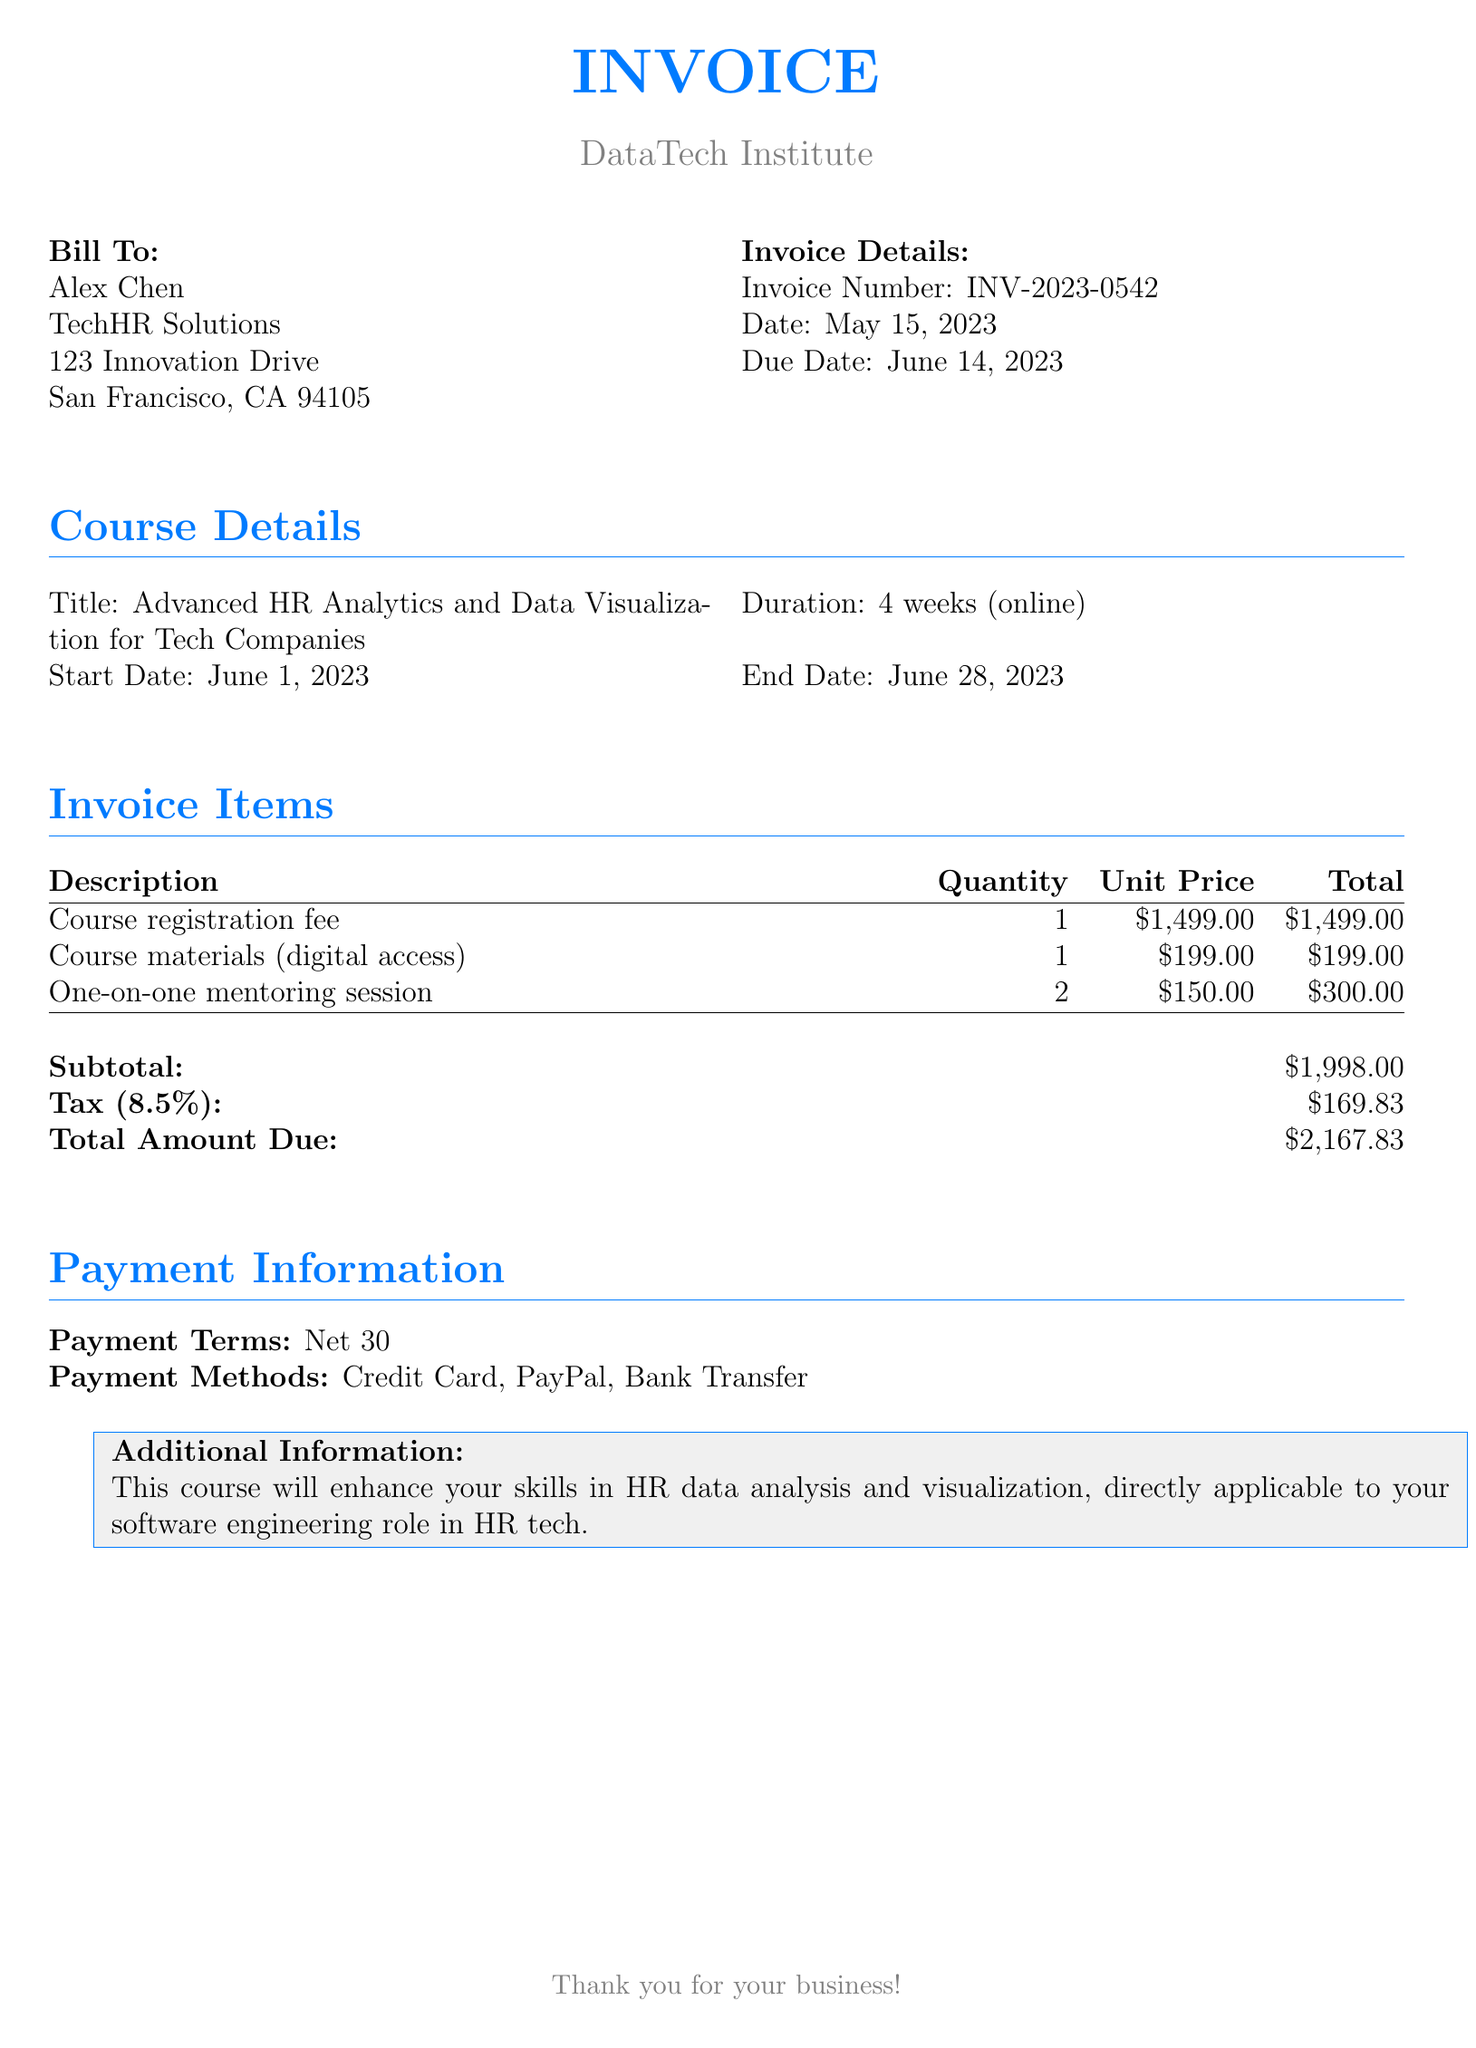What is the invoice number? The invoice number is listed in the invoice details section, which is INV-2023-0542.
Answer: INV-2023-0542 What is the total amount due? The total amount due is calculated from the subtotal and tax, which equals $2,167.83.
Answer: $2,167.83 What is the start date of the course? The start date is mentioned in the course details section, which is June 1, 2023.
Answer: June 1, 2023 How many one-on-one mentoring sessions are included? The number of mentoring sessions is specified in the invoice items, which indicates 2 sessions are included.
Answer: 2 What is the duration of the course? The duration is stated in the course details, which is 4 weeks (online).
Answer: 4 weeks (online) What is the tax rate applied to the subtotal? The tax rate is indicated in the invoice summary as 8.5%.
Answer: 8.5% What are the payment terms? The payment terms are clearly mentioned in the payment information section as "Net 30."
Answer: Net 30 What services are included in the invoice items? The services provided are listed, including course registration fee, course materials, and mentoring sessions.
Answer: Course registration fee, course materials, one-on-one mentoring session 